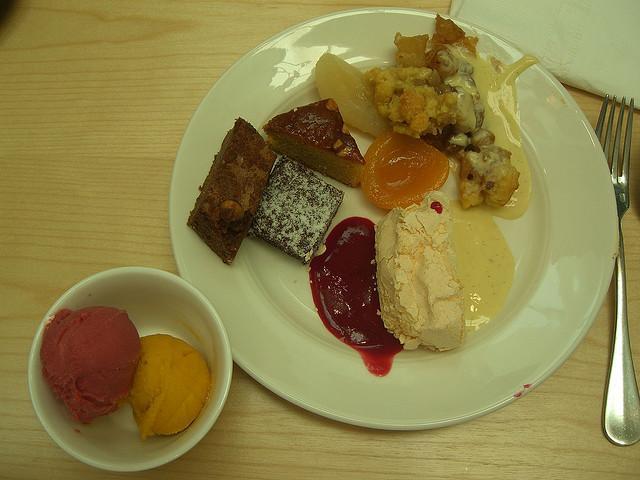How many tools are in this picture?
Give a very brief answer. 1. How many cakes can you see?
Give a very brief answer. 2. How many people are on bikes?
Give a very brief answer. 0. 